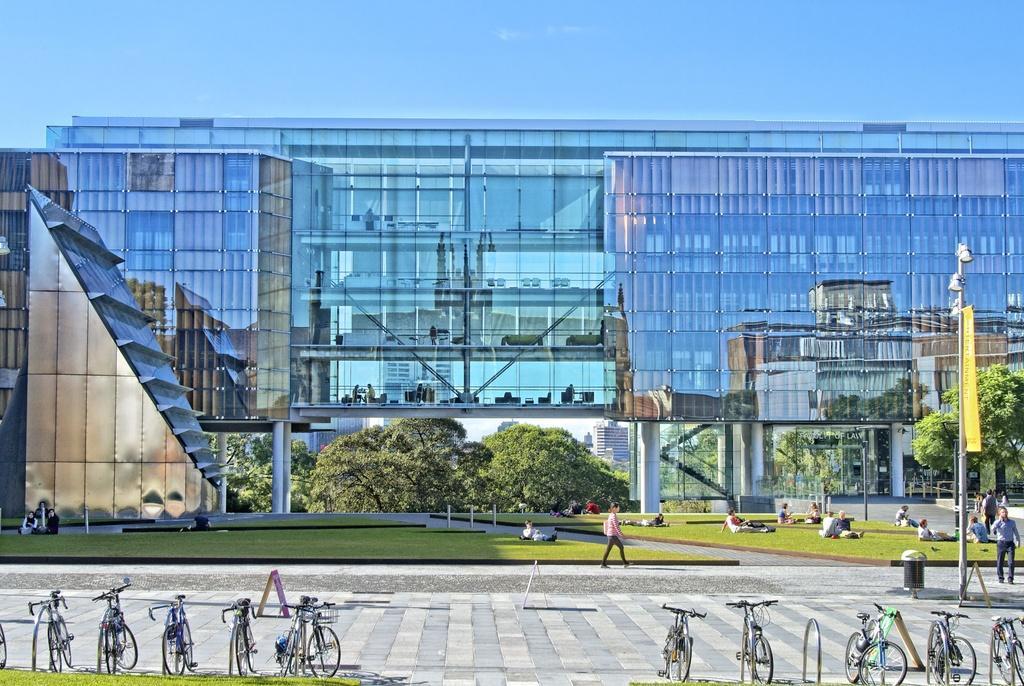How would you summarize this image in a sentence or two? In this image, I can see a building with the glass doors. These are the pillars. I can see few people sitting and few people walking. These are the bicycles, which are parked. This looks like a banner, which is hanging to a pole. I can see the trees. This is the grass. This looks like a pathway. Here is the sky. 